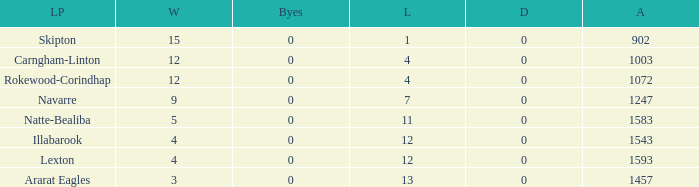What is the most wins with 0 byes? None. 